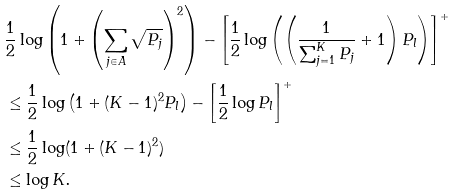<formula> <loc_0><loc_0><loc_500><loc_500>& \frac { 1 } { 2 } \log \left ( 1 + \left ( \sum _ { j \in A } \sqrt { P _ { j } } \right ) ^ { 2 } \right ) - \left [ \frac { 1 } { 2 } \log \left ( \left ( \frac { 1 } { \sum _ { j = 1 } ^ { K } P _ { j } } + 1 \right ) P _ { l } \right ) \right ] ^ { + } \\ & \leq \frac { 1 } { 2 } \log \left ( 1 + ( K - 1 ) ^ { 2 } P _ { l } \right ) - \left [ \frac { 1 } { 2 } \log P _ { l } \right ] ^ { + } \\ & \leq \frac { 1 } { 2 } \log ( 1 + ( K - 1 ) ^ { 2 } ) \\ & \leq \log K \text  .</formula> 